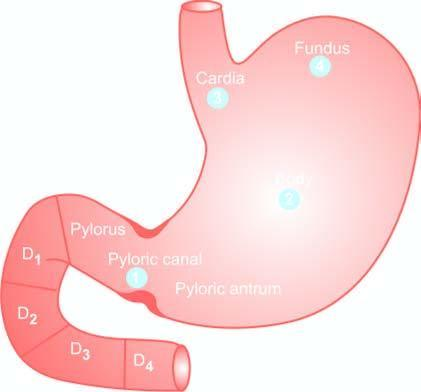do the serial numbers in the figure indicate the order of frequency of occurrence of gastric cancer?
Answer the question using a single word or phrase. Yes 